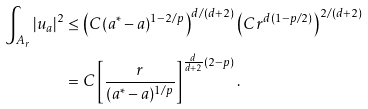Convert formula to latex. <formula><loc_0><loc_0><loc_500><loc_500>\int _ { A _ { r } } | u _ { a } | ^ { 2 } & \leq \left ( C ( a ^ { * } - a ) ^ { 1 - 2 / p } \right ) ^ { d / ( d + 2 ) } \left ( C r ^ { d ( 1 - p / 2 ) } \right ) ^ { 2 / ( d + 2 ) } \\ & = C \left [ \frac { r } { ( a ^ { * } - a ) ^ { 1 / p } } \right ] ^ { \frac { d } { d + 2 } ( 2 - p ) } .</formula> 